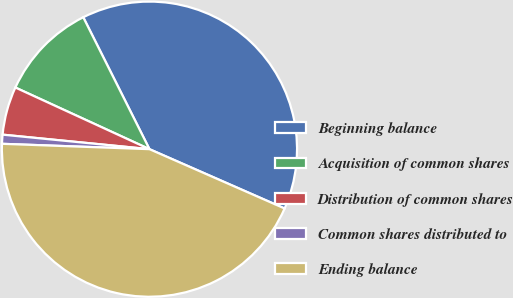Convert chart. <chart><loc_0><loc_0><loc_500><loc_500><pie_chart><fcel>Beginning balance<fcel>Acquisition of common shares<fcel>Distribution of common shares<fcel>Common shares distributed to<fcel>Ending balance<nl><fcel>38.99%<fcel>10.74%<fcel>5.29%<fcel>0.99%<fcel>44.0%<nl></chart> 